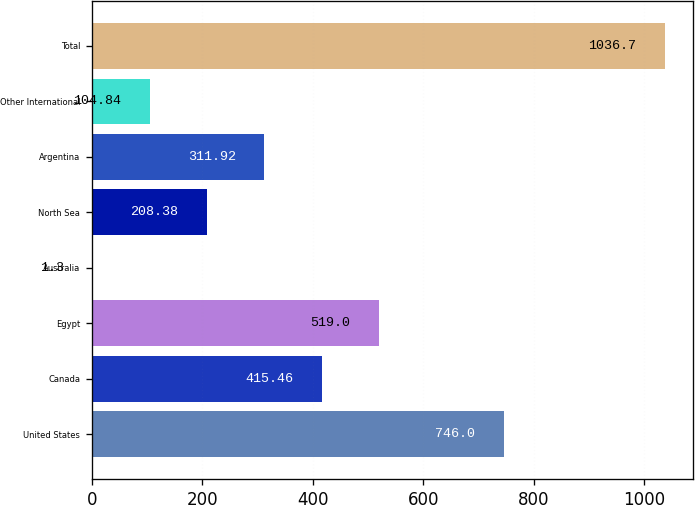Convert chart. <chart><loc_0><loc_0><loc_500><loc_500><bar_chart><fcel>United States<fcel>Canada<fcel>Egypt<fcel>Australia<fcel>North Sea<fcel>Argentina<fcel>Other International<fcel>Total<nl><fcel>746<fcel>415.46<fcel>519<fcel>1.3<fcel>208.38<fcel>311.92<fcel>104.84<fcel>1036.7<nl></chart> 